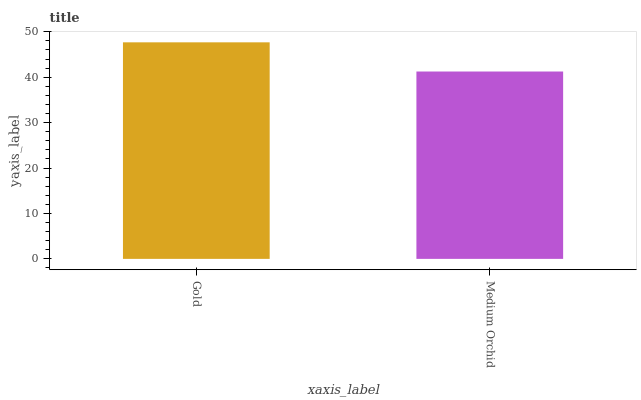Is Medium Orchid the minimum?
Answer yes or no. Yes. Is Gold the maximum?
Answer yes or no. Yes. Is Medium Orchid the maximum?
Answer yes or no. No. Is Gold greater than Medium Orchid?
Answer yes or no. Yes. Is Medium Orchid less than Gold?
Answer yes or no. Yes. Is Medium Orchid greater than Gold?
Answer yes or no. No. Is Gold less than Medium Orchid?
Answer yes or no. No. Is Gold the high median?
Answer yes or no. Yes. Is Medium Orchid the low median?
Answer yes or no. Yes. Is Medium Orchid the high median?
Answer yes or no. No. Is Gold the low median?
Answer yes or no. No. 